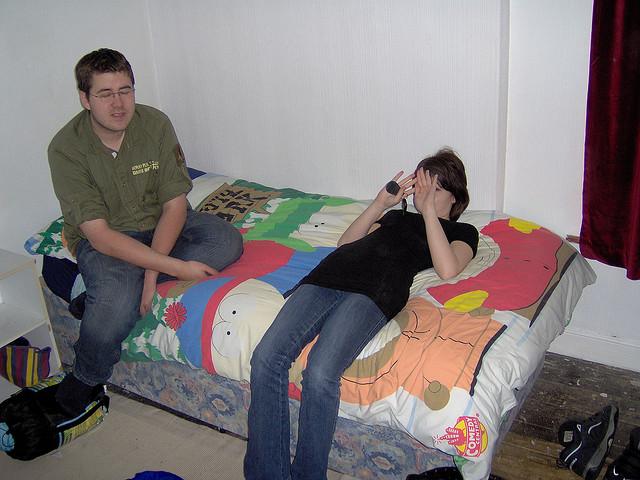What is the man looking at?
Keep it brief. Wall. Where are they waiting?
Answer briefly. Bedroom. What is the girl sitting on?
Keep it brief. Bed. What size bed is this?
Answer briefly. Twin. How many people are in this picture?
Quick response, please. 2. What is on the woman's face?
Keep it brief. Hands. Are these two happy?
Keep it brief. No. What kind of shoes are lying around the room?
Answer briefly. Sneakers. What is on the wrist of the women?
Be succinct. Nothing. What pattern is the blanket?
Concise answer only. South park. What characters are on the bedspread?
Keep it brief. South park. What two letters on are on his shirt?
Be succinct. Ts. What color is the girl's shirt?
Concise answer only. Black. What is in the females hand?
Give a very brief answer. Keys. 